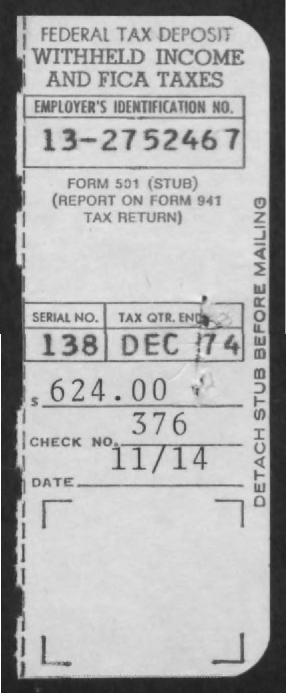List a handful of essential elements in this visual. An Employer Identification Number (EIN) is a unique number assigned to a business by the Internal Revenue Service (IRS) for tax purposes. The EIN for 13-2752467 is a specific number assigned to a business for tax identification. The end of the tax quarter is December 1974. What is the check number? It is 376. 